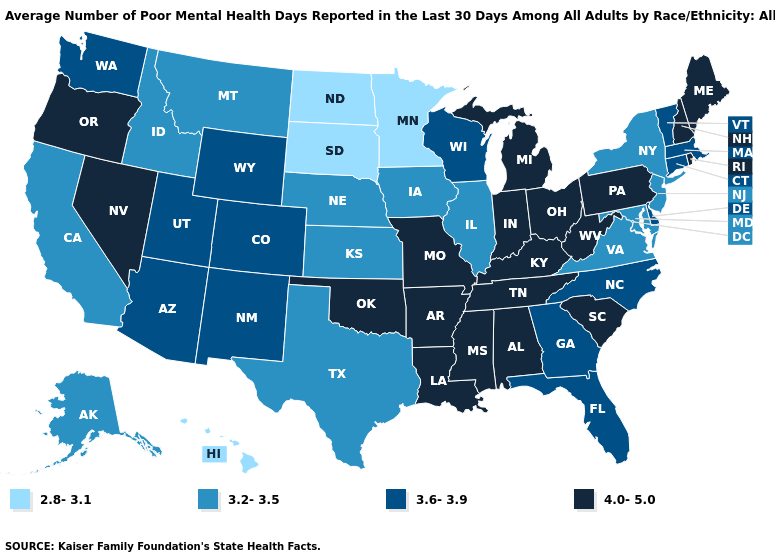Among the states that border Mississippi , which have the highest value?
Be succinct. Alabama, Arkansas, Louisiana, Tennessee. Does Florida have the same value as Louisiana?
Quick response, please. No. Does Nebraska have the highest value in the MidWest?
Quick response, please. No. What is the value of Michigan?
Quick response, please. 4.0-5.0. Does South Dakota have the lowest value in the USA?
Give a very brief answer. Yes. Among the states that border Kansas , does Missouri have the lowest value?
Keep it brief. No. Does Nebraska have the highest value in the USA?
Quick response, please. No. Among the states that border Maryland , which have the highest value?
Concise answer only. Pennsylvania, West Virginia. Name the states that have a value in the range 3.6-3.9?
Give a very brief answer. Arizona, Colorado, Connecticut, Delaware, Florida, Georgia, Massachusetts, New Mexico, North Carolina, Utah, Vermont, Washington, Wisconsin, Wyoming. Which states have the lowest value in the Northeast?
Be succinct. New Jersey, New York. What is the value of California?
Answer briefly. 3.2-3.5. What is the value of New Hampshire?
Short answer required. 4.0-5.0. What is the lowest value in the USA?
Be succinct. 2.8-3.1. What is the highest value in states that border Ohio?
Give a very brief answer. 4.0-5.0. Does the map have missing data?
Answer briefly. No. 